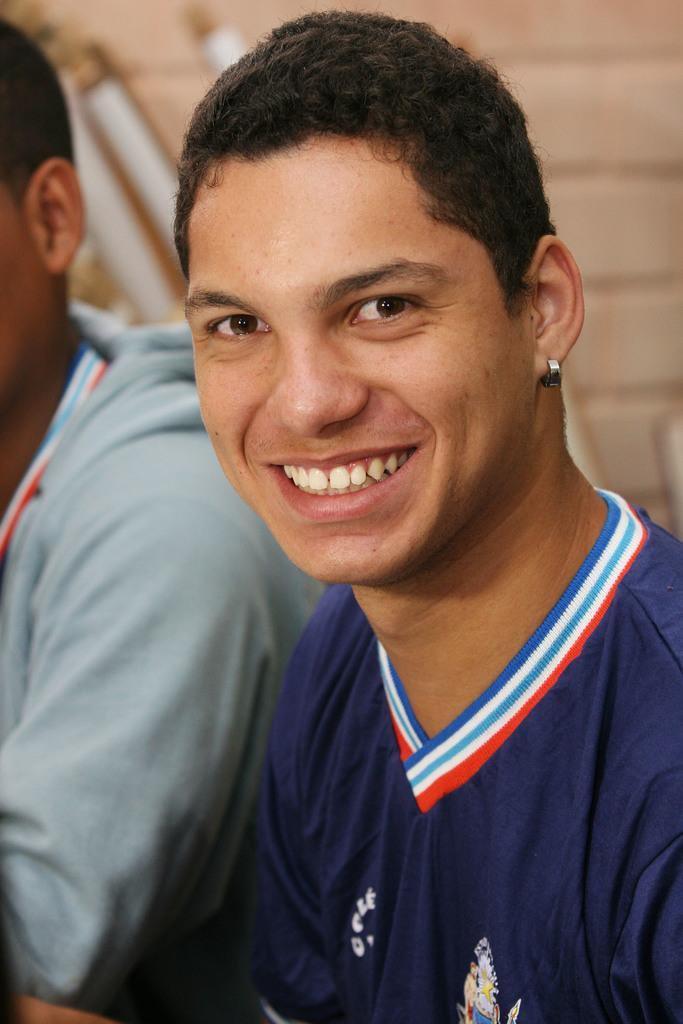Can you describe this image briefly? In this picture I can see a man in front and I see that he is wearing a t-shirt and I can also see that he is wearing a t-shirt and I can also see that he is smiling and beside to him, I can see another man. I see that it is blurred in the background. 